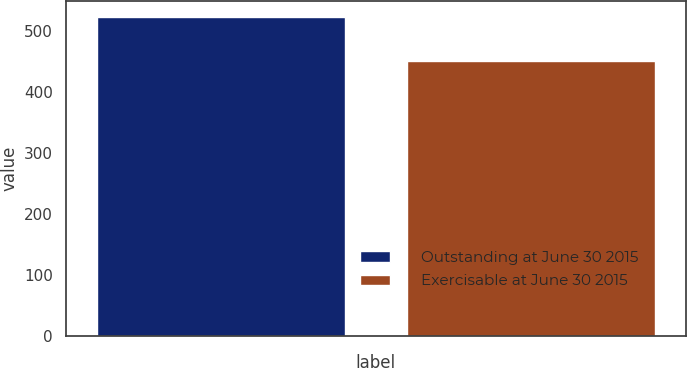<chart> <loc_0><loc_0><loc_500><loc_500><bar_chart><fcel>Outstanding at June 30 2015<fcel>Exercisable at June 30 2015<nl><fcel>523.1<fcel>450.9<nl></chart> 